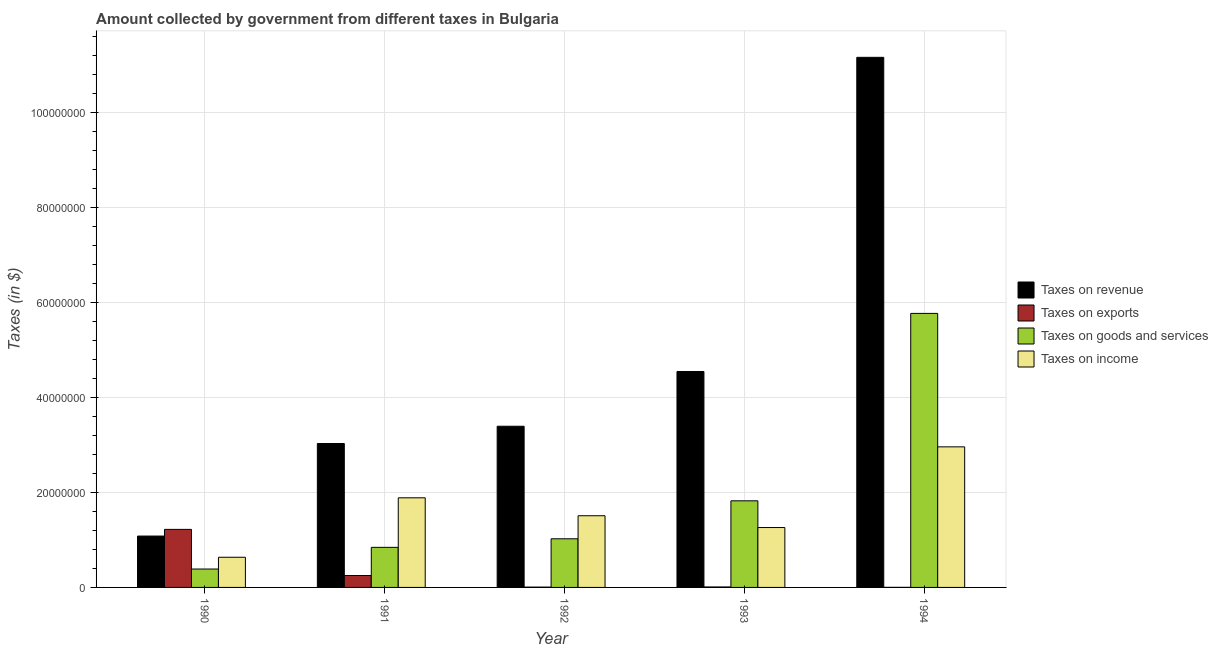How many different coloured bars are there?
Your answer should be very brief. 4. Are the number of bars per tick equal to the number of legend labels?
Offer a terse response. Yes. What is the label of the 5th group of bars from the left?
Ensure brevity in your answer.  1994. What is the amount collected as tax on revenue in 1990?
Your response must be concise. 1.08e+07. Across all years, what is the maximum amount collected as tax on income?
Provide a short and direct response. 2.96e+07. Across all years, what is the minimum amount collected as tax on income?
Keep it short and to the point. 6.35e+06. In which year was the amount collected as tax on exports maximum?
Offer a very short reply. 1990. In which year was the amount collected as tax on goods minimum?
Make the answer very short. 1990. What is the total amount collected as tax on exports in the graph?
Offer a very short reply. 1.49e+07. What is the difference between the amount collected as tax on exports in 1990 and that in 1992?
Your answer should be very brief. 1.22e+07. What is the difference between the amount collected as tax on goods in 1994 and the amount collected as tax on exports in 1990?
Provide a short and direct response. 5.38e+07. What is the average amount collected as tax on exports per year?
Your answer should be very brief. 2.98e+06. In how many years, is the amount collected as tax on goods greater than 96000000 $?
Keep it short and to the point. 0. What is the ratio of the amount collected as tax on revenue in 1990 to that in 1992?
Ensure brevity in your answer.  0.32. Is the amount collected as tax on goods in 1993 less than that in 1994?
Provide a short and direct response. Yes. What is the difference between the highest and the second highest amount collected as tax on income?
Offer a very short reply. 1.07e+07. What is the difference between the highest and the lowest amount collected as tax on income?
Ensure brevity in your answer.  2.33e+07. Is the sum of the amount collected as tax on exports in 1990 and 1993 greater than the maximum amount collected as tax on income across all years?
Your answer should be compact. Yes. What does the 3rd bar from the left in 1991 represents?
Make the answer very short. Taxes on goods and services. What does the 1st bar from the right in 1991 represents?
Provide a succinct answer. Taxes on income. What is the difference between two consecutive major ticks on the Y-axis?
Make the answer very short. 2.00e+07. Does the graph contain any zero values?
Offer a terse response. No. What is the title of the graph?
Offer a very short reply. Amount collected by government from different taxes in Bulgaria. Does "UNHCR" appear as one of the legend labels in the graph?
Give a very brief answer. No. What is the label or title of the Y-axis?
Ensure brevity in your answer.  Taxes (in $). What is the Taxes (in $) in Taxes on revenue in 1990?
Offer a terse response. 1.08e+07. What is the Taxes (in $) of Taxes on exports in 1990?
Offer a terse response. 1.22e+07. What is the Taxes (in $) in Taxes on goods and services in 1990?
Your answer should be compact. 3.88e+06. What is the Taxes (in $) in Taxes on income in 1990?
Ensure brevity in your answer.  6.35e+06. What is the Taxes (in $) in Taxes on revenue in 1991?
Give a very brief answer. 3.03e+07. What is the Taxes (in $) of Taxes on exports in 1991?
Provide a short and direct response. 2.51e+06. What is the Taxes (in $) in Taxes on goods and services in 1991?
Provide a short and direct response. 8.44e+06. What is the Taxes (in $) of Taxes on income in 1991?
Ensure brevity in your answer.  1.89e+07. What is the Taxes (in $) in Taxes on revenue in 1992?
Offer a very short reply. 3.39e+07. What is the Taxes (in $) in Taxes on exports in 1992?
Offer a terse response. 6.80e+04. What is the Taxes (in $) of Taxes on goods and services in 1992?
Ensure brevity in your answer.  1.02e+07. What is the Taxes (in $) in Taxes on income in 1992?
Provide a short and direct response. 1.51e+07. What is the Taxes (in $) of Taxes on revenue in 1993?
Keep it short and to the point. 4.55e+07. What is the Taxes (in $) of Taxes on exports in 1993?
Make the answer very short. 9.91e+04. What is the Taxes (in $) of Taxes on goods and services in 1993?
Ensure brevity in your answer.  1.82e+07. What is the Taxes (in $) of Taxes on income in 1993?
Ensure brevity in your answer.  1.26e+07. What is the Taxes (in $) in Taxes on revenue in 1994?
Your answer should be compact. 1.12e+08. What is the Taxes (in $) of Taxes on exports in 1994?
Make the answer very short. 1.46e+04. What is the Taxes (in $) in Taxes on goods and services in 1994?
Your response must be concise. 5.77e+07. What is the Taxes (in $) of Taxes on income in 1994?
Your answer should be compact. 2.96e+07. Across all years, what is the maximum Taxes (in $) of Taxes on revenue?
Your response must be concise. 1.12e+08. Across all years, what is the maximum Taxes (in $) of Taxes on exports?
Your response must be concise. 1.22e+07. Across all years, what is the maximum Taxes (in $) in Taxes on goods and services?
Your answer should be very brief. 5.77e+07. Across all years, what is the maximum Taxes (in $) of Taxes on income?
Your answer should be very brief. 2.96e+07. Across all years, what is the minimum Taxes (in $) of Taxes on revenue?
Keep it short and to the point. 1.08e+07. Across all years, what is the minimum Taxes (in $) in Taxes on exports?
Make the answer very short. 1.46e+04. Across all years, what is the minimum Taxes (in $) in Taxes on goods and services?
Offer a very short reply. 3.88e+06. Across all years, what is the minimum Taxes (in $) in Taxes on income?
Provide a short and direct response. 6.35e+06. What is the total Taxes (in $) in Taxes on revenue in the graph?
Provide a succinct answer. 2.32e+08. What is the total Taxes (in $) of Taxes on exports in the graph?
Provide a succinct answer. 1.49e+07. What is the total Taxes (in $) of Taxes on goods and services in the graph?
Make the answer very short. 9.85e+07. What is the total Taxes (in $) in Taxes on income in the graph?
Keep it short and to the point. 8.25e+07. What is the difference between the Taxes (in $) of Taxes on revenue in 1990 and that in 1991?
Offer a terse response. -1.95e+07. What is the difference between the Taxes (in $) of Taxes on exports in 1990 and that in 1991?
Ensure brevity in your answer.  9.71e+06. What is the difference between the Taxes (in $) of Taxes on goods and services in 1990 and that in 1991?
Your response must be concise. -4.56e+06. What is the difference between the Taxes (in $) of Taxes on income in 1990 and that in 1991?
Your answer should be compact. -1.25e+07. What is the difference between the Taxes (in $) of Taxes on revenue in 1990 and that in 1992?
Keep it short and to the point. -2.31e+07. What is the difference between the Taxes (in $) of Taxes on exports in 1990 and that in 1992?
Make the answer very short. 1.22e+07. What is the difference between the Taxes (in $) in Taxes on goods and services in 1990 and that in 1992?
Your answer should be compact. -6.37e+06. What is the difference between the Taxes (in $) in Taxes on income in 1990 and that in 1992?
Give a very brief answer. -8.74e+06. What is the difference between the Taxes (in $) in Taxes on revenue in 1990 and that in 1993?
Offer a very short reply. -3.47e+07. What is the difference between the Taxes (in $) of Taxes on exports in 1990 and that in 1993?
Offer a very short reply. 1.21e+07. What is the difference between the Taxes (in $) of Taxes on goods and services in 1990 and that in 1993?
Your answer should be very brief. -1.44e+07. What is the difference between the Taxes (in $) in Taxes on income in 1990 and that in 1993?
Offer a very short reply. -6.26e+06. What is the difference between the Taxes (in $) of Taxes on revenue in 1990 and that in 1994?
Keep it short and to the point. -1.01e+08. What is the difference between the Taxes (in $) in Taxes on exports in 1990 and that in 1994?
Give a very brief answer. 1.22e+07. What is the difference between the Taxes (in $) of Taxes on goods and services in 1990 and that in 1994?
Provide a succinct answer. -5.38e+07. What is the difference between the Taxes (in $) of Taxes on income in 1990 and that in 1994?
Provide a succinct answer. -2.33e+07. What is the difference between the Taxes (in $) in Taxes on revenue in 1991 and that in 1992?
Offer a very short reply. -3.64e+06. What is the difference between the Taxes (in $) in Taxes on exports in 1991 and that in 1992?
Your response must be concise. 2.44e+06. What is the difference between the Taxes (in $) in Taxes on goods and services in 1991 and that in 1992?
Your response must be concise. -1.80e+06. What is the difference between the Taxes (in $) of Taxes on income in 1991 and that in 1992?
Ensure brevity in your answer.  3.78e+06. What is the difference between the Taxes (in $) of Taxes on revenue in 1991 and that in 1993?
Keep it short and to the point. -1.52e+07. What is the difference between the Taxes (in $) of Taxes on exports in 1991 and that in 1993?
Your answer should be compact. 2.41e+06. What is the difference between the Taxes (in $) of Taxes on goods and services in 1991 and that in 1993?
Keep it short and to the point. -9.80e+06. What is the difference between the Taxes (in $) of Taxes on income in 1991 and that in 1993?
Provide a short and direct response. 6.26e+06. What is the difference between the Taxes (in $) of Taxes on revenue in 1991 and that in 1994?
Provide a short and direct response. -8.13e+07. What is the difference between the Taxes (in $) of Taxes on exports in 1991 and that in 1994?
Ensure brevity in your answer.  2.50e+06. What is the difference between the Taxes (in $) in Taxes on goods and services in 1991 and that in 1994?
Provide a short and direct response. -4.93e+07. What is the difference between the Taxes (in $) in Taxes on income in 1991 and that in 1994?
Your answer should be compact. -1.07e+07. What is the difference between the Taxes (in $) in Taxes on revenue in 1992 and that in 1993?
Your answer should be compact. -1.15e+07. What is the difference between the Taxes (in $) of Taxes on exports in 1992 and that in 1993?
Your response must be concise. -3.11e+04. What is the difference between the Taxes (in $) of Taxes on goods and services in 1992 and that in 1993?
Offer a very short reply. -8.00e+06. What is the difference between the Taxes (in $) of Taxes on income in 1992 and that in 1993?
Your answer should be compact. 2.48e+06. What is the difference between the Taxes (in $) of Taxes on revenue in 1992 and that in 1994?
Keep it short and to the point. -7.77e+07. What is the difference between the Taxes (in $) of Taxes on exports in 1992 and that in 1994?
Offer a very short reply. 5.34e+04. What is the difference between the Taxes (in $) in Taxes on goods and services in 1992 and that in 1994?
Give a very brief answer. -4.75e+07. What is the difference between the Taxes (in $) of Taxes on income in 1992 and that in 1994?
Provide a succinct answer. -1.45e+07. What is the difference between the Taxes (in $) in Taxes on revenue in 1993 and that in 1994?
Offer a terse response. -6.62e+07. What is the difference between the Taxes (in $) in Taxes on exports in 1993 and that in 1994?
Your answer should be compact. 8.45e+04. What is the difference between the Taxes (in $) of Taxes on goods and services in 1993 and that in 1994?
Your answer should be very brief. -3.95e+07. What is the difference between the Taxes (in $) in Taxes on income in 1993 and that in 1994?
Provide a succinct answer. -1.70e+07. What is the difference between the Taxes (in $) in Taxes on revenue in 1990 and the Taxes (in $) in Taxes on exports in 1991?
Your answer should be very brief. 8.31e+06. What is the difference between the Taxes (in $) in Taxes on revenue in 1990 and the Taxes (in $) in Taxes on goods and services in 1991?
Your response must be concise. 2.38e+06. What is the difference between the Taxes (in $) of Taxes on revenue in 1990 and the Taxes (in $) of Taxes on income in 1991?
Give a very brief answer. -8.06e+06. What is the difference between the Taxes (in $) of Taxes on exports in 1990 and the Taxes (in $) of Taxes on goods and services in 1991?
Give a very brief answer. 3.78e+06. What is the difference between the Taxes (in $) in Taxes on exports in 1990 and the Taxes (in $) in Taxes on income in 1991?
Keep it short and to the point. -6.65e+06. What is the difference between the Taxes (in $) of Taxes on goods and services in 1990 and the Taxes (in $) of Taxes on income in 1991?
Provide a short and direct response. -1.50e+07. What is the difference between the Taxes (in $) in Taxes on revenue in 1990 and the Taxes (in $) in Taxes on exports in 1992?
Your response must be concise. 1.08e+07. What is the difference between the Taxes (in $) of Taxes on revenue in 1990 and the Taxes (in $) of Taxes on goods and services in 1992?
Give a very brief answer. 5.76e+05. What is the difference between the Taxes (in $) in Taxes on revenue in 1990 and the Taxes (in $) in Taxes on income in 1992?
Offer a terse response. -4.28e+06. What is the difference between the Taxes (in $) of Taxes on exports in 1990 and the Taxes (in $) of Taxes on goods and services in 1992?
Your answer should be very brief. 1.98e+06. What is the difference between the Taxes (in $) in Taxes on exports in 1990 and the Taxes (in $) in Taxes on income in 1992?
Give a very brief answer. -2.87e+06. What is the difference between the Taxes (in $) in Taxes on goods and services in 1990 and the Taxes (in $) in Taxes on income in 1992?
Provide a short and direct response. -1.12e+07. What is the difference between the Taxes (in $) in Taxes on revenue in 1990 and the Taxes (in $) in Taxes on exports in 1993?
Your answer should be compact. 1.07e+07. What is the difference between the Taxes (in $) of Taxes on revenue in 1990 and the Taxes (in $) of Taxes on goods and services in 1993?
Give a very brief answer. -7.42e+06. What is the difference between the Taxes (in $) of Taxes on revenue in 1990 and the Taxes (in $) of Taxes on income in 1993?
Offer a terse response. -1.80e+06. What is the difference between the Taxes (in $) in Taxes on exports in 1990 and the Taxes (in $) in Taxes on goods and services in 1993?
Your answer should be very brief. -6.02e+06. What is the difference between the Taxes (in $) in Taxes on exports in 1990 and the Taxes (in $) in Taxes on income in 1993?
Your answer should be compact. -3.91e+05. What is the difference between the Taxes (in $) of Taxes on goods and services in 1990 and the Taxes (in $) of Taxes on income in 1993?
Your answer should be very brief. -8.74e+06. What is the difference between the Taxes (in $) in Taxes on revenue in 1990 and the Taxes (in $) in Taxes on exports in 1994?
Offer a very short reply. 1.08e+07. What is the difference between the Taxes (in $) in Taxes on revenue in 1990 and the Taxes (in $) in Taxes on goods and services in 1994?
Your answer should be very brief. -4.69e+07. What is the difference between the Taxes (in $) in Taxes on revenue in 1990 and the Taxes (in $) in Taxes on income in 1994?
Ensure brevity in your answer.  -1.88e+07. What is the difference between the Taxes (in $) of Taxes on exports in 1990 and the Taxes (in $) of Taxes on goods and services in 1994?
Your answer should be very brief. -4.55e+07. What is the difference between the Taxes (in $) in Taxes on exports in 1990 and the Taxes (in $) in Taxes on income in 1994?
Keep it short and to the point. -1.74e+07. What is the difference between the Taxes (in $) in Taxes on goods and services in 1990 and the Taxes (in $) in Taxes on income in 1994?
Your response must be concise. -2.57e+07. What is the difference between the Taxes (in $) of Taxes on revenue in 1991 and the Taxes (in $) of Taxes on exports in 1992?
Give a very brief answer. 3.02e+07. What is the difference between the Taxes (in $) of Taxes on revenue in 1991 and the Taxes (in $) of Taxes on goods and services in 1992?
Make the answer very short. 2.01e+07. What is the difference between the Taxes (in $) in Taxes on revenue in 1991 and the Taxes (in $) in Taxes on income in 1992?
Your answer should be compact. 1.52e+07. What is the difference between the Taxes (in $) of Taxes on exports in 1991 and the Taxes (in $) of Taxes on goods and services in 1992?
Provide a succinct answer. -7.73e+06. What is the difference between the Taxes (in $) of Taxes on exports in 1991 and the Taxes (in $) of Taxes on income in 1992?
Your answer should be compact. -1.26e+07. What is the difference between the Taxes (in $) in Taxes on goods and services in 1991 and the Taxes (in $) in Taxes on income in 1992?
Offer a terse response. -6.66e+06. What is the difference between the Taxes (in $) in Taxes on revenue in 1991 and the Taxes (in $) in Taxes on exports in 1993?
Your answer should be compact. 3.02e+07. What is the difference between the Taxes (in $) of Taxes on revenue in 1991 and the Taxes (in $) of Taxes on goods and services in 1993?
Provide a succinct answer. 1.21e+07. What is the difference between the Taxes (in $) in Taxes on revenue in 1991 and the Taxes (in $) in Taxes on income in 1993?
Your answer should be compact. 1.77e+07. What is the difference between the Taxes (in $) in Taxes on exports in 1991 and the Taxes (in $) in Taxes on goods and services in 1993?
Ensure brevity in your answer.  -1.57e+07. What is the difference between the Taxes (in $) of Taxes on exports in 1991 and the Taxes (in $) of Taxes on income in 1993?
Ensure brevity in your answer.  -1.01e+07. What is the difference between the Taxes (in $) in Taxes on goods and services in 1991 and the Taxes (in $) in Taxes on income in 1993?
Provide a short and direct response. -4.18e+06. What is the difference between the Taxes (in $) of Taxes on revenue in 1991 and the Taxes (in $) of Taxes on exports in 1994?
Offer a terse response. 3.03e+07. What is the difference between the Taxes (in $) of Taxes on revenue in 1991 and the Taxes (in $) of Taxes on goods and services in 1994?
Make the answer very short. -2.74e+07. What is the difference between the Taxes (in $) in Taxes on revenue in 1991 and the Taxes (in $) in Taxes on income in 1994?
Your answer should be very brief. 7.02e+05. What is the difference between the Taxes (in $) in Taxes on exports in 1991 and the Taxes (in $) in Taxes on goods and services in 1994?
Provide a short and direct response. -5.52e+07. What is the difference between the Taxes (in $) of Taxes on exports in 1991 and the Taxes (in $) of Taxes on income in 1994?
Give a very brief answer. -2.71e+07. What is the difference between the Taxes (in $) of Taxes on goods and services in 1991 and the Taxes (in $) of Taxes on income in 1994?
Provide a succinct answer. -2.12e+07. What is the difference between the Taxes (in $) of Taxes on revenue in 1992 and the Taxes (in $) of Taxes on exports in 1993?
Make the answer very short. 3.38e+07. What is the difference between the Taxes (in $) in Taxes on revenue in 1992 and the Taxes (in $) in Taxes on goods and services in 1993?
Make the answer very short. 1.57e+07. What is the difference between the Taxes (in $) of Taxes on revenue in 1992 and the Taxes (in $) of Taxes on income in 1993?
Ensure brevity in your answer.  2.13e+07. What is the difference between the Taxes (in $) in Taxes on exports in 1992 and the Taxes (in $) in Taxes on goods and services in 1993?
Ensure brevity in your answer.  -1.82e+07. What is the difference between the Taxes (in $) in Taxes on exports in 1992 and the Taxes (in $) in Taxes on income in 1993?
Ensure brevity in your answer.  -1.25e+07. What is the difference between the Taxes (in $) in Taxes on goods and services in 1992 and the Taxes (in $) in Taxes on income in 1993?
Make the answer very short. -2.37e+06. What is the difference between the Taxes (in $) of Taxes on revenue in 1992 and the Taxes (in $) of Taxes on exports in 1994?
Offer a terse response. 3.39e+07. What is the difference between the Taxes (in $) of Taxes on revenue in 1992 and the Taxes (in $) of Taxes on goods and services in 1994?
Give a very brief answer. -2.38e+07. What is the difference between the Taxes (in $) in Taxes on revenue in 1992 and the Taxes (in $) in Taxes on income in 1994?
Your answer should be very brief. 4.34e+06. What is the difference between the Taxes (in $) in Taxes on exports in 1992 and the Taxes (in $) in Taxes on goods and services in 1994?
Make the answer very short. -5.76e+07. What is the difference between the Taxes (in $) of Taxes on exports in 1992 and the Taxes (in $) of Taxes on income in 1994?
Your answer should be compact. -2.95e+07. What is the difference between the Taxes (in $) of Taxes on goods and services in 1992 and the Taxes (in $) of Taxes on income in 1994?
Offer a very short reply. -1.94e+07. What is the difference between the Taxes (in $) of Taxes on revenue in 1993 and the Taxes (in $) of Taxes on exports in 1994?
Make the answer very short. 4.55e+07. What is the difference between the Taxes (in $) of Taxes on revenue in 1993 and the Taxes (in $) of Taxes on goods and services in 1994?
Your answer should be very brief. -1.22e+07. What is the difference between the Taxes (in $) in Taxes on revenue in 1993 and the Taxes (in $) in Taxes on income in 1994?
Keep it short and to the point. 1.59e+07. What is the difference between the Taxes (in $) of Taxes on exports in 1993 and the Taxes (in $) of Taxes on goods and services in 1994?
Ensure brevity in your answer.  -5.76e+07. What is the difference between the Taxes (in $) of Taxes on exports in 1993 and the Taxes (in $) of Taxes on income in 1994?
Your answer should be compact. -2.95e+07. What is the difference between the Taxes (in $) of Taxes on goods and services in 1993 and the Taxes (in $) of Taxes on income in 1994?
Your answer should be compact. -1.14e+07. What is the average Taxes (in $) of Taxes on revenue per year?
Provide a short and direct response. 4.64e+07. What is the average Taxes (in $) in Taxes on exports per year?
Give a very brief answer. 2.98e+06. What is the average Taxes (in $) in Taxes on goods and services per year?
Provide a succinct answer. 1.97e+07. What is the average Taxes (in $) in Taxes on income per year?
Provide a succinct answer. 1.65e+07. In the year 1990, what is the difference between the Taxes (in $) of Taxes on revenue and Taxes (in $) of Taxes on exports?
Offer a very short reply. -1.40e+06. In the year 1990, what is the difference between the Taxes (in $) in Taxes on revenue and Taxes (in $) in Taxes on goods and services?
Your answer should be very brief. 6.94e+06. In the year 1990, what is the difference between the Taxes (in $) of Taxes on revenue and Taxes (in $) of Taxes on income?
Provide a succinct answer. 4.46e+06. In the year 1990, what is the difference between the Taxes (in $) of Taxes on exports and Taxes (in $) of Taxes on goods and services?
Offer a very short reply. 8.35e+06. In the year 1990, what is the difference between the Taxes (in $) of Taxes on exports and Taxes (in $) of Taxes on income?
Your answer should be very brief. 5.87e+06. In the year 1990, what is the difference between the Taxes (in $) of Taxes on goods and services and Taxes (in $) of Taxes on income?
Keep it short and to the point. -2.48e+06. In the year 1991, what is the difference between the Taxes (in $) in Taxes on revenue and Taxes (in $) in Taxes on exports?
Provide a short and direct response. 2.78e+07. In the year 1991, what is the difference between the Taxes (in $) in Taxes on revenue and Taxes (in $) in Taxes on goods and services?
Provide a succinct answer. 2.19e+07. In the year 1991, what is the difference between the Taxes (in $) in Taxes on revenue and Taxes (in $) in Taxes on income?
Your answer should be compact. 1.14e+07. In the year 1991, what is the difference between the Taxes (in $) of Taxes on exports and Taxes (in $) of Taxes on goods and services?
Your answer should be compact. -5.93e+06. In the year 1991, what is the difference between the Taxes (in $) in Taxes on exports and Taxes (in $) in Taxes on income?
Give a very brief answer. -1.64e+07. In the year 1991, what is the difference between the Taxes (in $) of Taxes on goods and services and Taxes (in $) of Taxes on income?
Provide a succinct answer. -1.04e+07. In the year 1992, what is the difference between the Taxes (in $) of Taxes on revenue and Taxes (in $) of Taxes on exports?
Ensure brevity in your answer.  3.39e+07. In the year 1992, what is the difference between the Taxes (in $) of Taxes on revenue and Taxes (in $) of Taxes on goods and services?
Make the answer very short. 2.37e+07. In the year 1992, what is the difference between the Taxes (in $) in Taxes on revenue and Taxes (in $) in Taxes on income?
Your answer should be very brief. 1.88e+07. In the year 1992, what is the difference between the Taxes (in $) of Taxes on exports and Taxes (in $) of Taxes on goods and services?
Your answer should be compact. -1.02e+07. In the year 1992, what is the difference between the Taxes (in $) of Taxes on exports and Taxes (in $) of Taxes on income?
Provide a succinct answer. -1.50e+07. In the year 1992, what is the difference between the Taxes (in $) in Taxes on goods and services and Taxes (in $) in Taxes on income?
Keep it short and to the point. -4.85e+06. In the year 1993, what is the difference between the Taxes (in $) in Taxes on revenue and Taxes (in $) in Taxes on exports?
Offer a terse response. 4.54e+07. In the year 1993, what is the difference between the Taxes (in $) in Taxes on revenue and Taxes (in $) in Taxes on goods and services?
Your response must be concise. 2.72e+07. In the year 1993, what is the difference between the Taxes (in $) in Taxes on revenue and Taxes (in $) in Taxes on income?
Provide a succinct answer. 3.29e+07. In the year 1993, what is the difference between the Taxes (in $) of Taxes on exports and Taxes (in $) of Taxes on goods and services?
Offer a terse response. -1.81e+07. In the year 1993, what is the difference between the Taxes (in $) of Taxes on exports and Taxes (in $) of Taxes on income?
Ensure brevity in your answer.  -1.25e+07. In the year 1993, what is the difference between the Taxes (in $) of Taxes on goods and services and Taxes (in $) of Taxes on income?
Provide a succinct answer. 5.62e+06. In the year 1994, what is the difference between the Taxes (in $) in Taxes on revenue and Taxes (in $) in Taxes on exports?
Offer a very short reply. 1.12e+08. In the year 1994, what is the difference between the Taxes (in $) of Taxes on revenue and Taxes (in $) of Taxes on goods and services?
Provide a short and direct response. 5.39e+07. In the year 1994, what is the difference between the Taxes (in $) in Taxes on revenue and Taxes (in $) in Taxes on income?
Keep it short and to the point. 8.20e+07. In the year 1994, what is the difference between the Taxes (in $) of Taxes on exports and Taxes (in $) of Taxes on goods and services?
Provide a short and direct response. -5.77e+07. In the year 1994, what is the difference between the Taxes (in $) in Taxes on exports and Taxes (in $) in Taxes on income?
Ensure brevity in your answer.  -2.96e+07. In the year 1994, what is the difference between the Taxes (in $) of Taxes on goods and services and Taxes (in $) of Taxes on income?
Your response must be concise. 2.81e+07. What is the ratio of the Taxes (in $) in Taxes on revenue in 1990 to that in 1991?
Offer a terse response. 0.36. What is the ratio of the Taxes (in $) of Taxes on exports in 1990 to that in 1991?
Keep it short and to the point. 4.87. What is the ratio of the Taxes (in $) in Taxes on goods and services in 1990 to that in 1991?
Offer a very short reply. 0.46. What is the ratio of the Taxes (in $) of Taxes on income in 1990 to that in 1991?
Make the answer very short. 0.34. What is the ratio of the Taxes (in $) in Taxes on revenue in 1990 to that in 1992?
Provide a short and direct response. 0.32. What is the ratio of the Taxes (in $) in Taxes on exports in 1990 to that in 1992?
Your response must be concise. 179.74. What is the ratio of the Taxes (in $) in Taxes on goods and services in 1990 to that in 1992?
Your response must be concise. 0.38. What is the ratio of the Taxes (in $) in Taxes on income in 1990 to that in 1992?
Provide a succinct answer. 0.42. What is the ratio of the Taxes (in $) in Taxes on revenue in 1990 to that in 1993?
Ensure brevity in your answer.  0.24. What is the ratio of the Taxes (in $) of Taxes on exports in 1990 to that in 1993?
Provide a short and direct response. 123.34. What is the ratio of the Taxes (in $) of Taxes on goods and services in 1990 to that in 1993?
Your answer should be compact. 0.21. What is the ratio of the Taxes (in $) of Taxes on income in 1990 to that in 1993?
Make the answer very short. 0.5. What is the ratio of the Taxes (in $) in Taxes on revenue in 1990 to that in 1994?
Make the answer very short. 0.1. What is the ratio of the Taxes (in $) in Taxes on exports in 1990 to that in 1994?
Provide a succinct answer. 837.12. What is the ratio of the Taxes (in $) in Taxes on goods and services in 1990 to that in 1994?
Your answer should be very brief. 0.07. What is the ratio of the Taxes (in $) of Taxes on income in 1990 to that in 1994?
Offer a very short reply. 0.21. What is the ratio of the Taxes (in $) of Taxes on revenue in 1991 to that in 1992?
Provide a short and direct response. 0.89. What is the ratio of the Taxes (in $) in Taxes on exports in 1991 to that in 1992?
Make the answer very short. 36.91. What is the ratio of the Taxes (in $) in Taxes on goods and services in 1991 to that in 1992?
Give a very brief answer. 0.82. What is the ratio of the Taxes (in $) in Taxes on income in 1991 to that in 1992?
Your answer should be compact. 1.25. What is the ratio of the Taxes (in $) in Taxes on revenue in 1991 to that in 1993?
Keep it short and to the point. 0.67. What is the ratio of the Taxes (in $) of Taxes on exports in 1991 to that in 1993?
Provide a succinct answer. 25.33. What is the ratio of the Taxes (in $) in Taxes on goods and services in 1991 to that in 1993?
Make the answer very short. 0.46. What is the ratio of the Taxes (in $) of Taxes on income in 1991 to that in 1993?
Keep it short and to the point. 1.5. What is the ratio of the Taxes (in $) in Taxes on revenue in 1991 to that in 1994?
Ensure brevity in your answer.  0.27. What is the ratio of the Taxes (in $) in Taxes on exports in 1991 to that in 1994?
Your answer should be very brief. 171.91. What is the ratio of the Taxes (in $) of Taxes on goods and services in 1991 to that in 1994?
Your answer should be very brief. 0.15. What is the ratio of the Taxes (in $) of Taxes on income in 1991 to that in 1994?
Your answer should be compact. 0.64. What is the ratio of the Taxes (in $) in Taxes on revenue in 1992 to that in 1993?
Give a very brief answer. 0.75. What is the ratio of the Taxes (in $) in Taxes on exports in 1992 to that in 1993?
Give a very brief answer. 0.69. What is the ratio of the Taxes (in $) in Taxes on goods and services in 1992 to that in 1993?
Your answer should be compact. 0.56. What is the ratio of the Taxes (in $) in Taxes on income in 1992 to that in 1993?
Offer a terse response. 1.2. What is the ratio of the Taxes (in $) of Taxes on revenue in 1992 to that in 1994?
Offer a terse response. 0.3. What is the ratio of the Taxes (in $) in Taxes on exports in 1992 to that in 1994?
Offer a terse response. 4.66. What is the ratio of the Taxes (in $) in Taxes on goods and services in 1992 to that in 1994?
Offer a terse response. 0.18. What is the ratio of the Taxes (in $) in Taxes on income in 1992 to that in 1994?
Offer a terse response. 0.51. What is the ratio of the Taxes (in $) in Taxes on revenue in 1993 to that in 1994?
Make the answer very short. 0.41. What is the ratio of the Taxes (in $) of Taxes on exports in 1993 to that in 1994?
Offer a very short reply. 6.79. What is the ratio of the Taxes (in $) of Taxes on goods and services in 1993 to that in 1994?
Ensure brevity in your answer.  0.32. What is the ratio of the Taxes (in $) of Taxes on income in 1993 to that in 1994?
Make the answer very short. 0.43. What is the difference between the highest and the second highest Taxes (in $) in Taxes on revenue?
Provide a short and direct response. 6.62e+07. What is the difference between the highest and the second highest Taxes (in $) in Taxes on exports?
Offer a very short reply. 9.71e+06. What is the difference between the highest and the second highest Taxes (in $) of Taxes on goods and services?
Your response must be concise. 3.95e+07. What is the difference between the highest and the second highest Taxes (in $) in Taxes on income?
Provide a succinct answer. 1.07e+07. What is the difference between the highest and the lowest Taxes (in $) of Taxes on revenue?
Offer a very short reply. 1.01e+08. What is the difference between the highest and the lowest Taxes (in $) in Taxes on exports?
Provide a succinct answer. 1.22e+07. What is the difference between the highest and the lowest Taxes (in $) of Taxes on goods and services?
Ensure brevity in your answer.  5.38e+07. What is the difference between the highest and the lowest Taxes (in $) of Taxes on income?
Your response must be concise. 2.33e+07. 